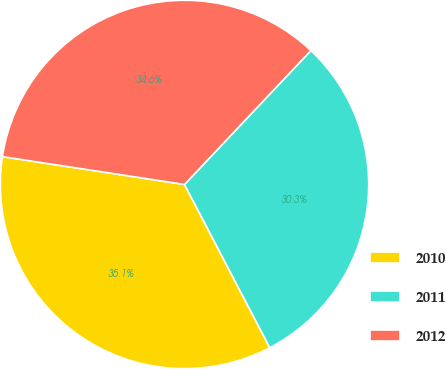Convert chart. <chart><loc_0><loc_0><loc_500><loc_500><pie_chart><fcel>2010<fcel>2011<fcel>2012<nl><fcel>35.08%<fcel>30.3%<fcel>34.63%<nl></chart> 